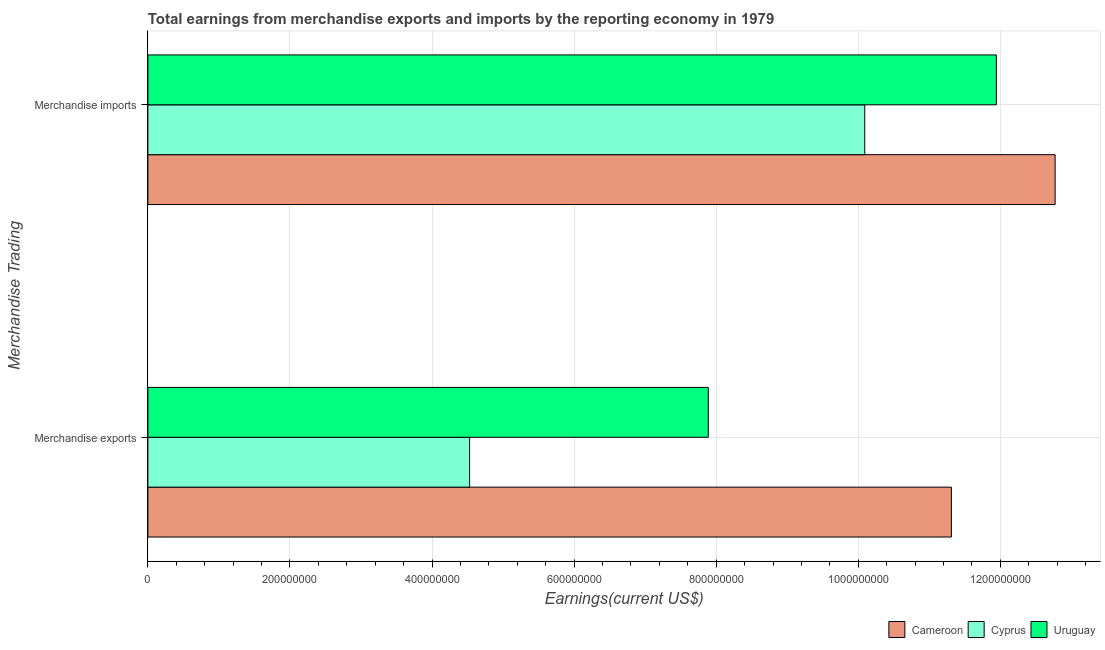How many different coloured bars are there?
Keep it short and to the point. 3. How many groups of bars are there?
Give a very brief answer. 2. Are the number of bars per tick equal to the number of legend labels?
Make the answer very short. Yes. How many bars are there on the 1st tick from the bottom?
Offer a very short reply. 3. What is the earnings from merchandise exports in Cyprus?
Provide a short and direct response. 4.53e+08. Across all countries, what is the maximum earnings from merchandise imports?
Provide a short and direct response. 1.28e+09. Across all countries, what is the minimum earnings from merchandise imports?
Your response must be concise. 1.01e+09. In which country was the earnings from merchandise imports maximum?
Your response must be concise. Cameroon. In which country was the earnings from merchandise exports minimum?
Make the answer very short. Cyprus. What is the total earnings from merchandise imports in the graph?
Provide a succinct answer. 3.48e+09. What is the difference between the earnings from merchandise exports in Cameroon and that in Cyprus?
Ensure brevity in your answer.  6.78e+08. What is the difference between the earnings from merchandise exports in Cameroon and the earnings from merchandise imports in Cyprus?
Provide a succinct answer. 1.22e+08. What is the average earnings from merchandise imports per country?
Ensure brevity in your answer.  1.16e+09. What is the difference between the earnings from merchandise exports and earnings from merchandise imports in Cameroon?
Make the answer very short. -1.46e+08. In how many countries, is the earnings from merchandise exports greater than 440000000 US$?
Give a very brief answer. 3. What is the ratio of the earnings from merchandise imports in Uruguay to that in Cyprus?
Your response must be concise. 1.18. Is the earnings from merchandise exports in Uruguay less than that in Cyprus?
Ensure brevity in your answer.  No. In how many countries, is the earnings from merchandise exports greater than the average earnings from merchandise exports taken over all countries?
Make the answer very short. 1. What does the 3rd bar from the top in Merchandise exports represents?
Keep it short and to the point. Cameroon. What does the 2nd bar from the bottom in Merchandise exports represents?
Ensure brevity in your answer.  Cyprus. How many bars are there?
Offer a terse response. 6. Are all the bars in the graph horizontal?
Give a very brief answer. Yes. How many countries are there in the graph?
Offer a terse response. 3. What is the difference between two consecutive major ticks on the X-axis?
Provide a short and direct response. 2.00e+08. Are the values on the major ticks of X-axis written in scientific E-notation?
Provide a short and direct response. No. Where does the legend appear in the graph?
Keep it short and to the point. Bottom right. How many legend labels are there?
Give a very brief answer. 3. How are the legend labels stacked?
Your response must be concise. Horizontal. What is the title of the graph?
Provide a short and direct response. Total earnings from merchandise exports and imports by the reporting economy in 1979. What is the label or title of the X-axis?
Give a very brief answer. Earnings(current US$). What is the label or title of the Y-axis?
Your answer should be very brief. Merchandise Trading. What is the Earnings(current US$) of Cameroon in Merchandise exports?
Make the answer very short. 1.13e+09. What is the Earnings(current US$) of Cyprus in Merchandise exports?
Provide a short and direct response. 4.53e+08. What is the Earnings(current US$) of Uruguay in Merchandise exports?
Give a very brief answer. 7.89e+08. What is the Earnings(current US$) in Cameroon in Merchandise imports?
Offer a terse response. 1.28e+09. What is the Earnings(current US$) of Cyprus in Merchandise imports?
Offer a very short reply. 1.01e+09. What is the Earnings(current US$) of Uruguay in Merchandise imports?
Ensure brevity in your answer.  1.19e+09. Across all Merchandise Trading, what is the maximum Earnings(current US$) of Cameroon?
Your response must be concise. 1.28e+09. Across all Merchandise Trading, what is the maximum Earnings(current US$) of Cyprus?
Ensure brevity in your answer.  1.01e+09. Across all Merchandise Trading, what is the maximum Earnings(current US$) of Uruguay?
Keep it short and to the point. 1.19e+09. Across all Merchandise Trading, what is the minimum Earnings(current US$) of Cameroon?
Offer a very short reply. 1.13e+09. Across all Merchandise Trading, what is the minimum Earnings(current US$) in Cyprus?
Keep it short and to the point. 4.53e+08. Across all Merchandise Trading, what is the minimum Earnings(current US$) in Uruguay?
Your response must be concise. 7.89e+08. What is the total Earnings(current US$) in Cameroon in the graph?
Provide a succinct answer. 2.41e+09. What is the total Earnings(current US$) of Cyprus in the graph?
Your answer should be compact. 1.46e+09. What is the total Earnings(current US$) in Uruguay in the graph?
Ensure brevity in your answer.  1.98e+09. What is the difference between the Earnings(current US$) of Cameroon in Merchandise exports and that in Merchandise imports?
Make the answer very short. -1.46e+08. What is the difference between the Earnings(current US$) in Cyprus in Merchandise exports and that in Merchandise imports?
Provide a short and direct response. -5.56e+08. What is the difference between the Earnings(current US$) in Uruguay in Merchandise exports and that in Merchandise imports?
Offer a very short reply. -4.06e+08. What is the difference between the Earnings(current US$) of Cameroon in Merchandise exports and the Earnings(current US$) of Cyprus in Merchandise imports?
Ensure brevity in your answer.  1.22e+08. What is the difference between the Earnings(current US$) of Cameroon in Merchandise exports and the Earnings(current US$) of Uruguay in Merchandise imports?
Ensure brevity in your answer.  -6.33e+07. What is the difference between the Earnings(current US$) of Cyprus in Merchandise exports and the Earnings(current US$) of Uruguay in Merchandise imports?
Your answer should be compact. -7.42e+08. What is the average Earnings(current US$) in Cameroon per Merchandise Trading?
Make the answer very short. 1.20e+09. What is the average Earnings(current US$) in Cyprus per Merchandise Trading?
Your answer should be compact. 7.31e+08. What is the average Earnings(current US$) in Uruguay per Merchandise Trading?
Keep it short and to the point. 9.92e+08. What is the difference between the Earnings(current US$) in Cameroon and Earnings(current US$) in Cyprus in Merchandise exports?
Give a very brief answer. 6.78e+08. What is the difference between the Earnings(current US$) in Cameroon and Earnings(current US$) in Uruguay in Merchandise exports?
Ensure brevity in your answer.  3.42e+08. What is the difference between the Earnings(current US$) in Cyprus and Earnings(current US$) in Uruguay in Merchandise exports?
Make the answer very short. -3.36e+08. What is the difference between the Earnings(current US$) in Cameroon and Earnings(current US$) in Cyprus in Merchandise imports?
Your answer should be compact. 2.68e+08. What is the difference between the Earnings(current US$) of Cameroon and Earnings(current US$) of Uruguay in Merchandise imports?
Offer a very short reply. 8.27e+07. What is the difference between the Earnings(current US$) in Cyprus and Earnings(current US$) in Uruguay in Merchandise imports?
Offer a very short reply. -1.85e+08. What is the ratio of the Earnings(current US$) in Cameroon in Merchandise exports to that in Merchandise imports?
Your answer should be compact. 0.89. What is the ratio of the Earnings(current US$) in Cyprus in Merchandise exports to that in Merchandise imports?
Provide a short and direct response. 0.45. What is the ratio of the Earnings(current US$) in Uruguay in Merchandise exports to that in Merchandise imports?
Your answer should be compact. 0.66. What is the difference between the highest and the second highest Earnings(current US$) of Cameroon?
Offer a terse response. 1.46e+08. What is the difference between the highest and the second highest Earnings(current US$) in Cyprus?
Give a very brief answer. 5.56e+08. What is the difference between the highest and the second highest Earnings(current US$) of Uruguay?
Your response must be concise. 4.06e+08. What is the difference between the highest and the lowest Earnings(current US$) in Cameroon?
Your answer should be compact. 1.46e+08. What is the difference between the highest and the lowest Earnings(current US$) of Cyprus?
Ensure brevity in your answer.  5.56e+08. What is the difference between the highest and the lowest Earnings(current US$) of Uruguay?
Your response must be concise. 4.06e+08. 